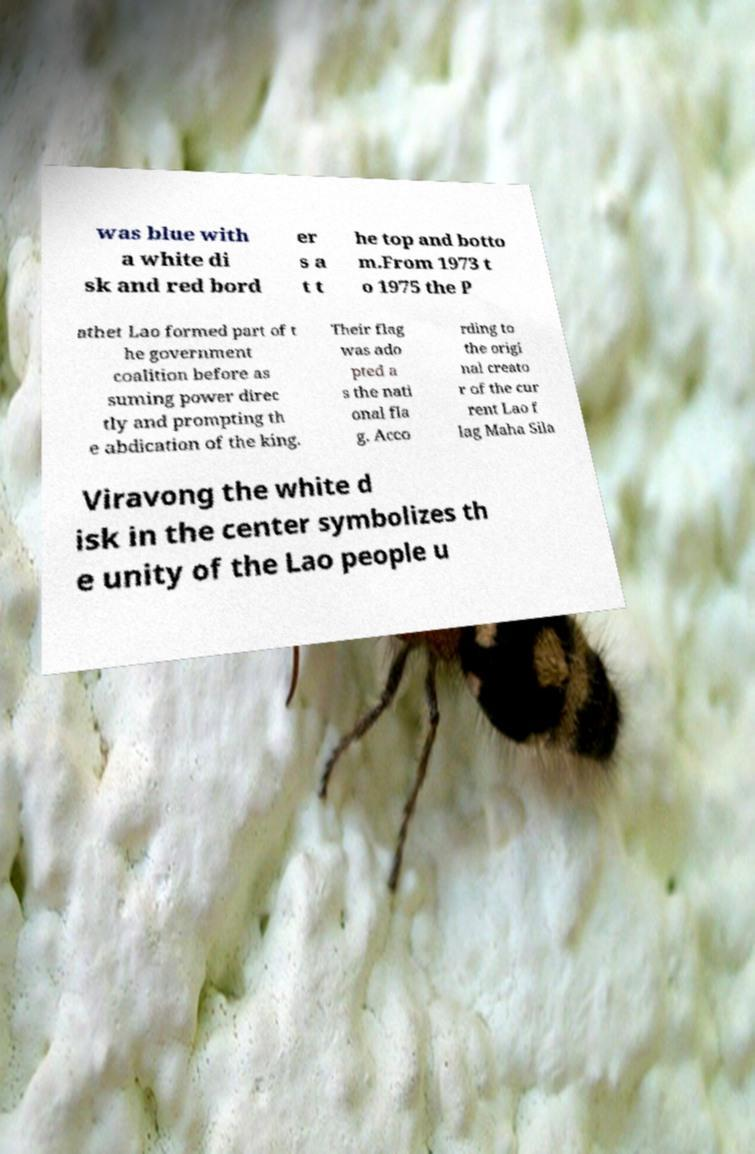Please read and relay the text visible in this image. What does it say? was blue with a white di sk and red bord er s a t t he top and botto m.From 1973 t o 1975 the P athet Lao formed part of t he government coalition before as suming power direc tly and prompting th e abdication of the king. Their flag was ado pted a s the nati onal fla g. Acco rding to the origi nal creato r of the cur rent Lao f lag Maha Sila Viravong the white d isk in the center symbolizes th e unity of the Lao people u 